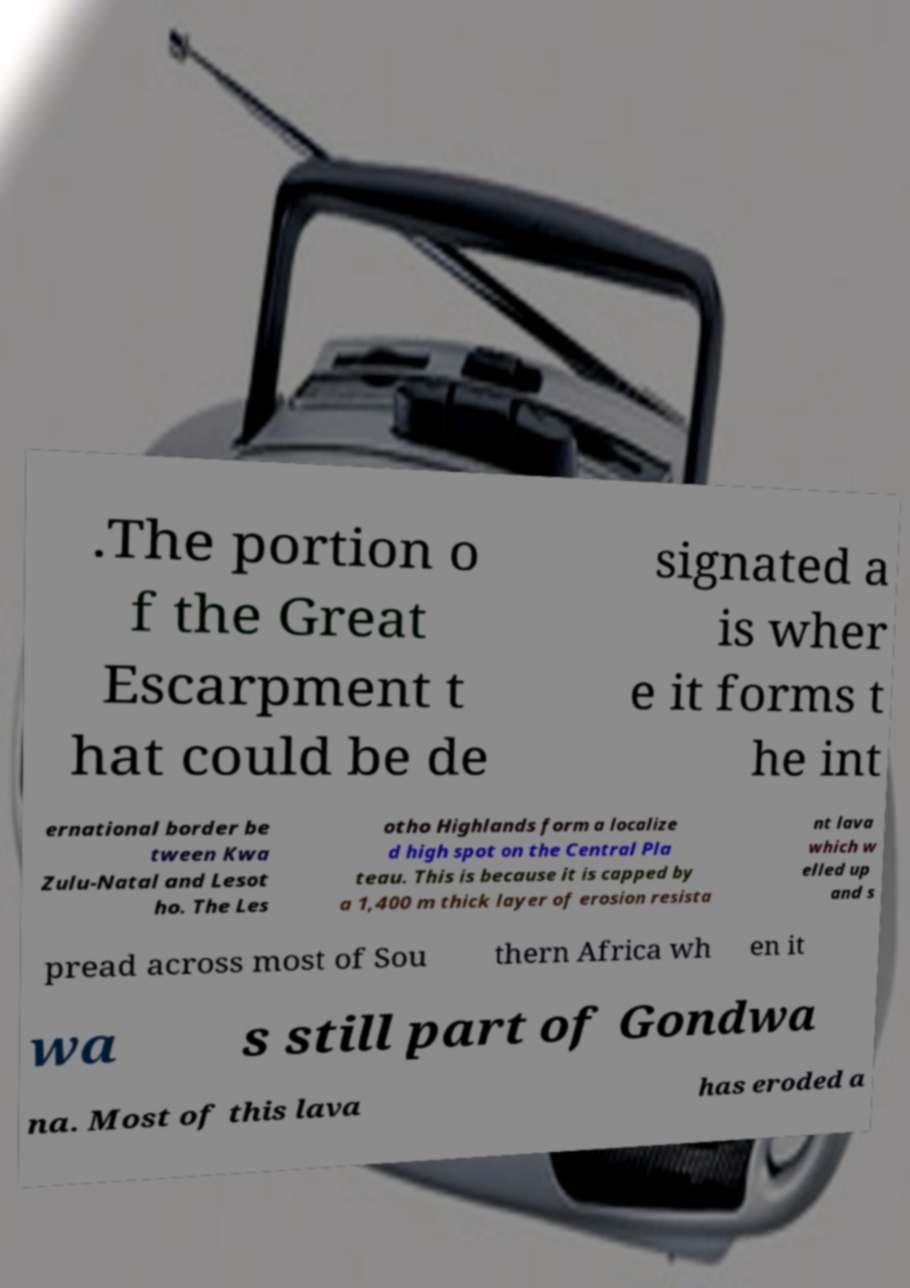Please identify and transcribe the text found in this image. .The portion o f the Great Escarpment t hat could be de signated a is wher e it forms t he int ernational border be tween Kwa Zulu-Natal and Lesot ho. The Les otho Highlands form a localize d high spot on the Central Pla teau. This is because it is capped by a 1,400 m thick layer of erosion resista nt lava which w elled up and s pread across most of Sou thern Africa wh en it wa s still part of Gondwa na. Most of this lava has eroded a 